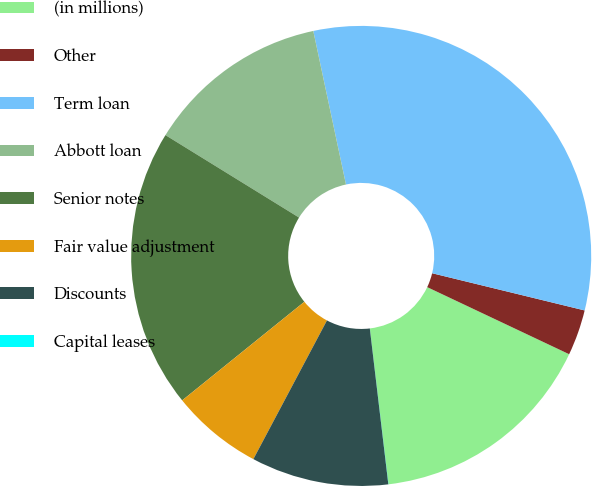Convert chart to OTSL. <chart><loc_0><loc_0><loc_500><loc_500><pie_chart><fcel>(in millions)<fcel>Other<fcel>Term loan<fcel>Abbott loan<fcel>Senior notes<fcel>Fair value adjustment<fcel>Discounts<fcel>Capital leases<nl><fcel>16.08%<fcel>3.22%<fcel>32.15%<fcel>12.86%<fcel>19.61%<fcel>6.43%<fcel>9.65%<fcel>0.01%<nl></chart> 